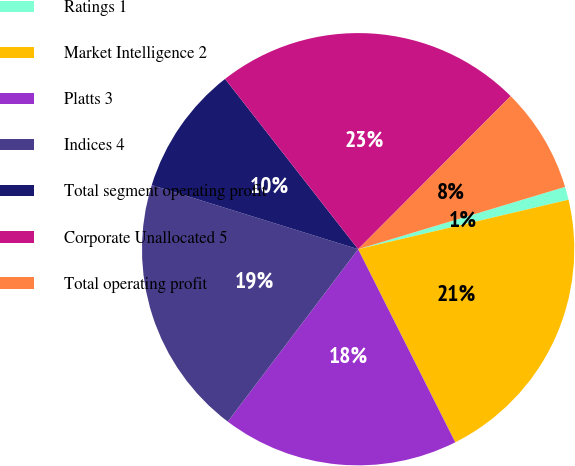Convert chart. <chart><loc_0><loc_0><loc_500><loc_500><pie_chart><fcel>Ratings 1<fcel>Market Intelligence 2<fcel>Platts 3<fcel>Indices 4<fcel>Total segment operating profit<fcel>Corporate Unallocated 5<fcel>Total operating profit<nl><fcel>0.98%<fcel>21.26%<fcel>17.72%<fcel>19.49%<fcel>9.65%<fcel>23.03%<fcel>7.87%<nl></chart> 